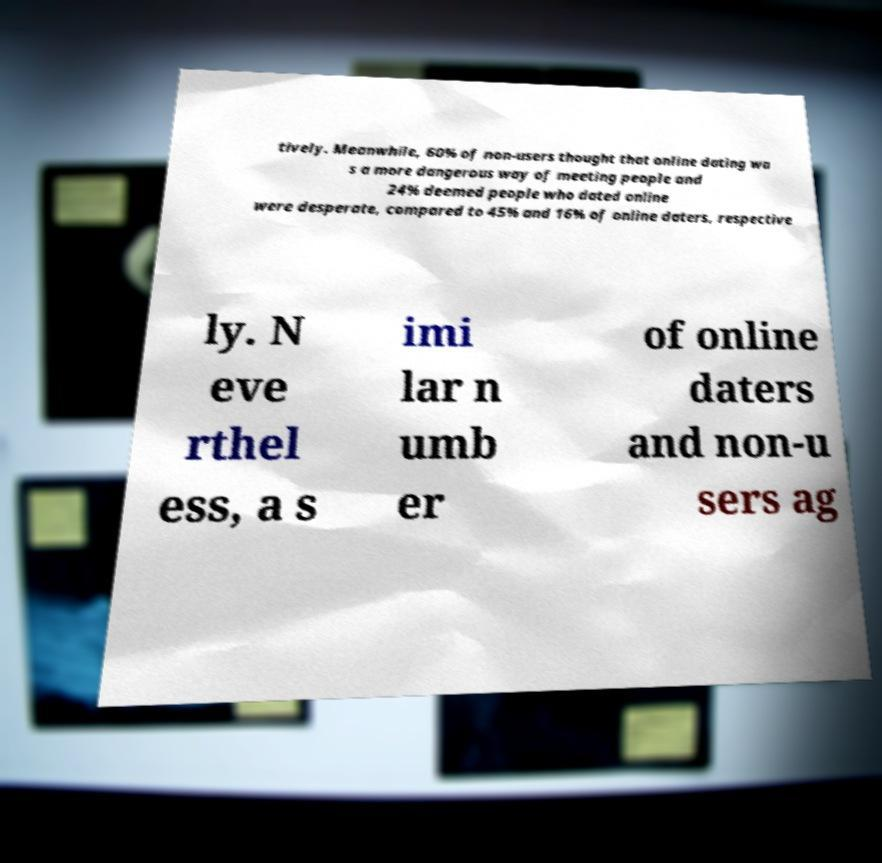What messages or text are displayed in this image? I need them in a readable, typed format. tively. Meanwhile, 60% of non-users thought that online dating wa s a more dangerous way of meeting people and 24% deemed people who dated online were desperate, compared to 45% and 16% of online daters, respective ly. N eve rthel ess, a s imi lar n umb er of online daters and non-u sers ag 